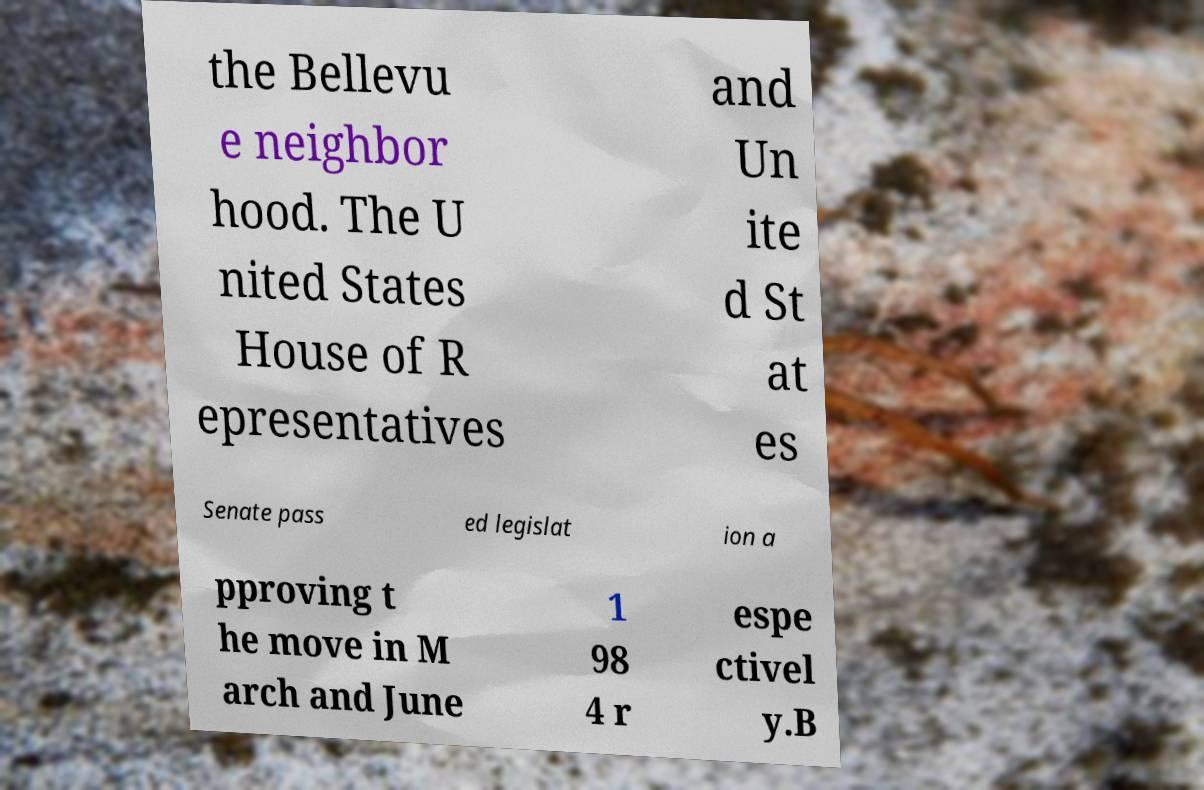I need the written content from this picture converted into text. Can you do that? the Bellevu e neighbor hood. The U nited States House of R epresentatives and Un ite d St at es Senate pass ed legislat ion a pproving t he move in M arch and June 1 98 4 r espe ctivel y.B 